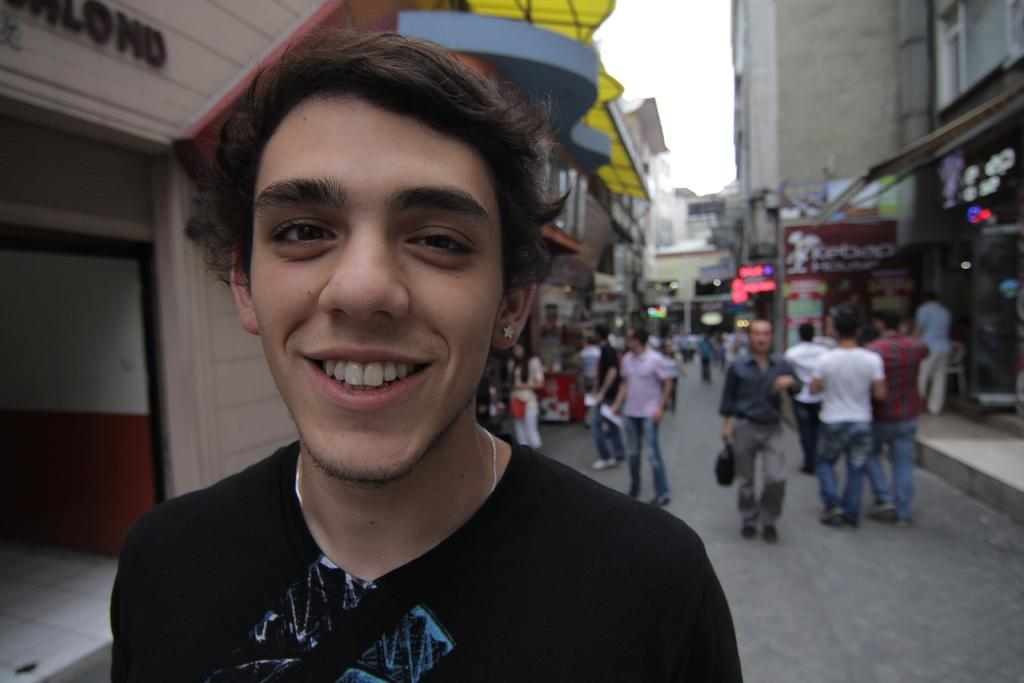Who is present in the image? There is a man in the image. What is the man doing in the image? The man is smiling in the image. What is the man wearing in the image? The man is wearing a black t-shirt in the image. What can be seen in the background of the image? There are people walking on the road and stores on the street in the background of the image. What type of thread is being used to sew the patch on the man's t-shirt in the image? There is no patch or thread visible on the man's t-shirt in the image; he is wearing a black t-shirt. 